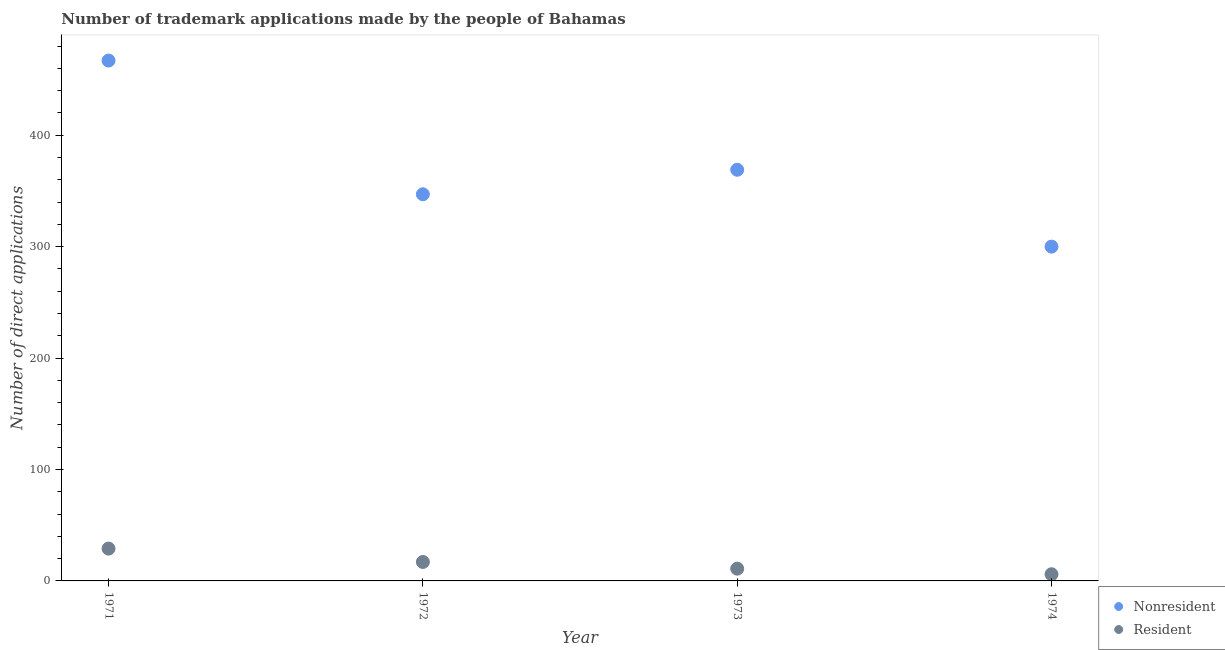How many different coloured dotlines are there?
Your response must be concise. 2. What is the number of trademark applications made by residents in 1971?
Give a very brief answer. 29. Across all years, what is the maximum number of trademark applications made by non residents?
Ensure brevity in your answer.  467. In which year was the number of trademark applications made by residents maximum?
Make the answer very short. 1971. In which year was the number of trademark applications made by residents minimum?
Your response must be concise. 1974. What is the total number of trademark applications made by residents in the graph?
Your answer should be compact. 63. What is the difference between the number of trademark applications made by residents in 1972 and that in 1974?
Provide a succinct answer. 11. What is the difference between the number of trademark applications made by residents in 1972 and the number of trademark applications made by non residents in 1973?
Your answer should be very brief. -352. What is the average number of trademark applications made by non residents per year?
Your answer should be compact. 370.75. In the year 1974, what is the difference between the number of trademark applications made by residents and number of trademark applications made by non residents?
Offer a very short reply. -294. In how many years, is the number of trademark applications made by non residents greater than 360?
Ensure brevity in your answer.  2. What is the ratio of the number of trademark applications made by residents in 1971 to that in 1972?
Keep it short and to the point. 1.71. What is the difference between the highest and the lowest number of trademark applications made by non residents?
Your answer should be very brief. 167. In how many years, is the number of trademark applications made by non residents greater than the average number of trademark applications made by non residents taken over all years?
Your response must be concise. 1. Is the sum of the number of trademark applications made by residents in 1972 and 1974 greater than the maximum number of trademark applications made by non residents across all years?
Keep it short and to the point. No. Does the number of trademark applications made by non residents monotonically increase over the years?
Give a very brief answer. No. How many dotlines are there?
Keep it short and to the point. 2. How many years are there in the graph?
Give a very brief answer. 4. Does the graph contain any zero values?
Give a very brief answer. No. Does the graph contain grids?
Offer a terse response. No. How many legend labels are there?
Provide a short and direct response. 2. How are the legend labels stacked?
Your answer should be very brief. Vertical. What is the title of the graph?
Provide a succinct answer. Number of trademark applications made by the people of Bahamas. What is the label or title of the Y-axis?
Your response must be concise. Number of direct applications. What is the Number of direct applications of Nonresident in 1971?
Give a very brief answer. 467. What is the Number of direct applications of Resident in 1971?
Ensure brevity in your answer.  29. What is the Number of direct applications in Nonresident in 1972?
Keep it short and to the point. 347. What is the Number of direct applications in Resident in 1972?
Offer a terse response. 17. What is the Number of direct applications of Nonresident in 1973?
Offer a very short reply. 369. What is the Number of direct applications in Nonresident in 1974?
Offer a very short reply. 300. Across all years, what is the maximum Number of direct applications of Nonresident?
Keep it short and to the point. 467. Across all years, what is the minimum Number of direct applications in Nonresident?
Your response must be concise. 300. What is the total Number of direct applications in Nonresident in the graph?
Your answer should be very brief. 1483. What is the difference between the Number of direct applications of Nonresident in 1971 and that in 1972?
Your response must be concise. 120. What is the difference between the Number of direct applications in Nonresident in 1971 and that in 1973?
Your answer should be compact. 98. What is the difference between the Number of direct applications of Resident in 1971 and that in 1973?
Ensure brevity in your answer.  18. What is the difference between the Number of direct applications of Nonresident in 1971 and that in 1974?
Your answer should be very brief. 167. What is the difference between the Number of direct applications of Resident in 1971 and that in 1974?
Your answer should be compact. 23. What is the difference between the Number of direct applications in Resident in 1972 and that in 1973?
Provide a succinct answer. 6. What is the difference between the Number of direct applications of Nonresident in 1973 and that in 1974?
Provide a succinct answer. 69. What is the difference between the Number of direct applications in Nonresident in 1971 and the Number of direct applications in Resident in 1972?
Your response must be concise. 450. What is the difference between the Number of direct applications in Nonresident in 1971 and the Number of direct applications in Resident in 1973?
Your response must be concise. 456. What is the difference between the Number of direct applications of Nonresident in 1971 and the Number of direct applications of Resident in 1974?
Make the answer very short. 461. What is the difference between the Number of direct applications of Nonresident in 1972 and the Number of direct applications of Resident in 1973?
Ensure brevity in your answer.  336. What is the difference between the Number of direct applications of Nonresident in 1972 and the Number of direct applications of Resident in 1974?
Ensure brevity in your answer.  341. What is the difference between the Number of direct applications of Nonresident in 1973 and the Number of direct applications of Resident in 1974?
Offer a terse response. 363. What is the average Number of direct applications of Nonresident per year?
Provide a succinct answer. 370.75. What is the average Number of direct applications of Resident per year?
Give a very brief answer. 15.75. In the year 1971, what is the difference between the Number of direct applications of Nonresident and Number of direct applications of Resident?
Provide a short and direct response. 438. In the year 1972, what is the difference between the Number of direct applications in Nonresident and Number of direct applications in Resident?
Make the answer very short. 330. In the year 1973, what is the difference between the Number of direct applications of Nonresident and Number of direct applications of Resident?
Offer a very short reply. 358. In the year 1974, what is the difference between the Number of direct applications of Nonresident and Number of direct applications of Resident?
Ensure brevity in your answer.  294. What is the ratio of the Number of direct applications in Nonresident in 1971 to that in 1972?
Provide a succinct answer. 1.35. What is the ratio of the Number of direct applications of Resident in 1971 to that in 1972?
Your response must be concise. 1.71. What is the ratio of the Number of direct applications of Nonresident in 1971 to that in 1973?
Your answer should be very brief. 1.27. What is the ratio of the Number of direct applications in Resident in 1971 to that in 1973?
Your answer should be compact. 2.64. What is the ratio of the Number of direct applications of Nonresident in 1971 to that in 1974?
Ensure brevity in your answer.  1.56. What is the ratio of the Number of direct applications of Resident in 1971 to that in 1974?
Keep it short and to the point. 4.83. What is the ratio of the Number of direct applications in Nonresident in 1972 to that in 1973?
Your answer should be compact. 0.94. What is the ratio of the Number of direct applications of Resident in 1972 to that in 1973?
Make the answer very short. 1.55. What is the ratio of the Number of direct applications in Nonresident in 1972 to that in 1974?
Ensure brevity in your answer.  1.16. What is the ratio of the Number of direct applications in Resident in 1972 to that in 1974?
Provide a short and direct response. 2.83. What is the ratio of the Number of direct applications in Nonresident in 1973 to that in 1974?
Your answer should be compact. 1.23. What is the ratio of the Number of direct applications of Resident in 1973 to that in 1974?
Your answer should be compact. 1.83. What is the difference between the highest and the second highest Number of direct applications in Resident?
Offer a very short reply. 12. What is the difference between the highest and the lowest Number of direct applications of Nonresident?
Offer a very short reply. 167. What is the difference between the highest and the lowest Number of direct applications of Resident?
Make the answer very short. 23. 